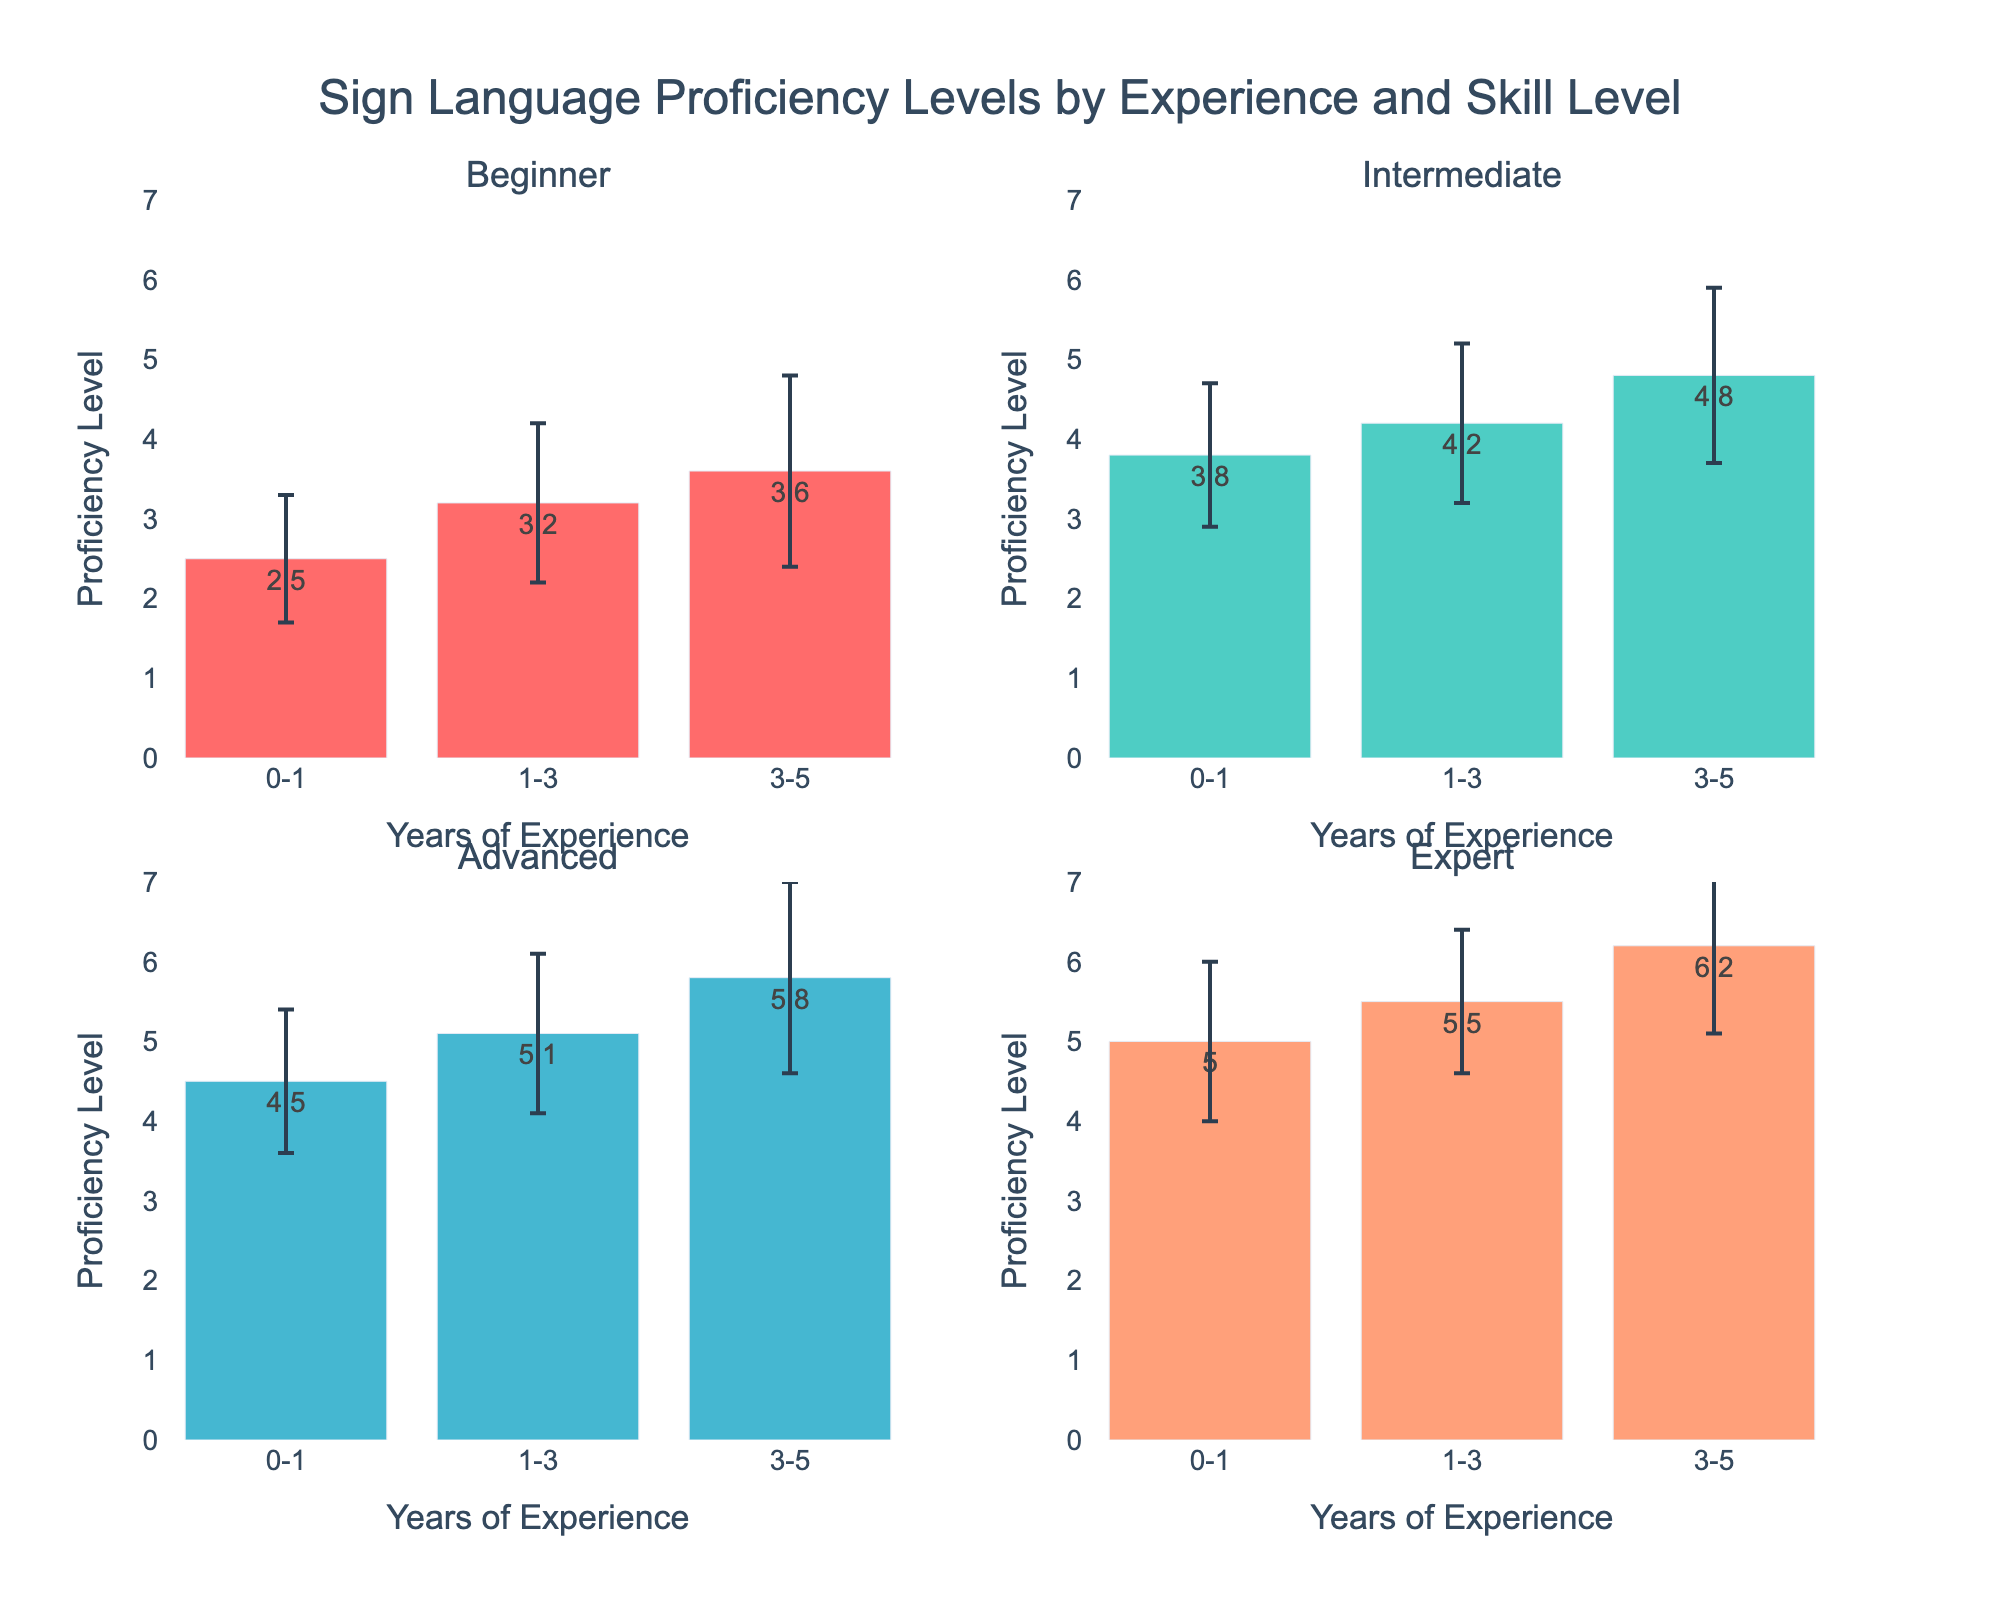What is the primary title of the figure? The primary title is usually found at the top of the figure and gives an overview of what the plot presents.
Answer: Sign Language Proficiency Levels by Experience and Skill Level Which proficiency level shows the highest mean proficiency for the 0-1 year experience group? Look at the bars corresponding to the 0-1 year experience group and identify the one with the greatest height.
Answer: Expert What is the range of the Y-axis in all subplots? The range of the Y-axis can be found on the Y-axis, typically starting from the bottom value to the top value indicated.
Answer: 0 to 7 How does the mean proficiency level for the Beginner group change with increasing years of experience? Observe the three bars in the Beginner subplot and note the changes in their heights for different experience groups (0-1, 1-3, 3-5 years).
Answer: Increases Who has a higher average proficiency level: Beginners with 3-5 years of experience or Intermediates with 0-1 year of experience? Compare the bars for Beginners with 3-5 years and Intermediates with 0-1 year in their respective subplots.
Answer: Intermediates with 0-1 year Which experience group has the highest error bar in the Advanced proficiency level? Look at the error bars (vertical lines) in the Advanced subplot and identify the tallest one.
Answer: 3-5 years Is the proficiency level variance higher for Beginners or Experts within the 1-3 year experience group? Compare the length of the error bars for the 1-3 year experience group within both the Beginner and Expert subplots.
Answer: Beginners What is the proficiency level difference between Intermediate and Advanced staff with 3-5 years of experience? Subtract the mean proficiency level of Intermediates with 3-5 years from that of Advanced staff with the same experience.
Answer: 1.0 Which proficiency level group demonstrates the least amount of change in mean proficiency over different experience groups? Examine the heights of bars within each proficiency level subplot and determine which group shows the smallest vertical differences between bars.
Answer: Expert How does the variability (standard deviation) for proficiency levels compare between Advanced and Expert staff with 0-1 year of experience? Compare the lengths of the error bars for Advanced and Expert subplots specifically for the 0-1 year experience group.
Answer: Similar 